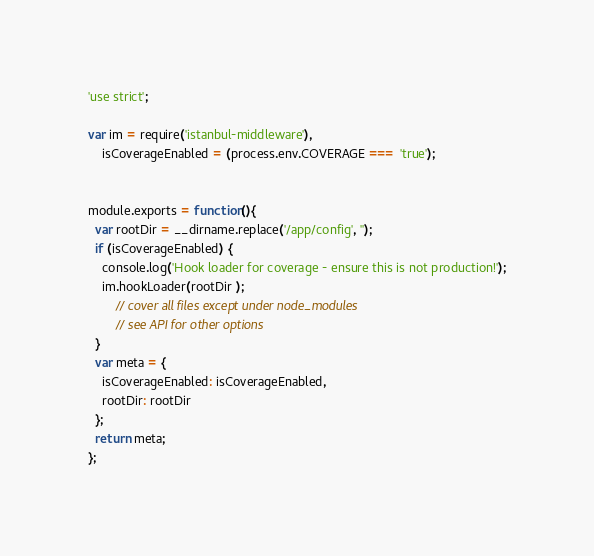<code> <loc_0><loc_0><loc_500><loc_500><_JavaScript_>'use strict';

var im = require('istanbul-middleware'),
    isCoverageEnabled = (process.env.COVERAGE === 'true');


module.exports = function(){
  var rootDir = __dirname.replace('/app/config', '');
  if (isCoverageEnabled) {
    console.log('Hook loader for coverage - ensure this is not production!');
    im.hookLoader(rootDir );
        // cover all files except under node_modules
        // see API for other options
  }
  var meta = {
    isCoverageEnabled: isCoverageEnabled,
    rootDir: rootDir
  };
  return meta;
};
</code> 